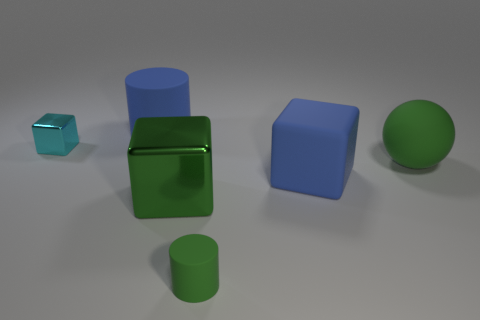Add 1 big rubber blocks. How many objects exist? 7 Subtract all balls. How many objects are left? 5 Add 1 blue matte objects. How many blue matte objects are left? 3 Add 2 large blue rubber cylinders. How many large blue rubber cylinders exist? 3 Subtract 0 brown spheres. How many objects are left? 6 Subtract all tiny green things. Subtract all red metal spheres. How many objects are left? 5 